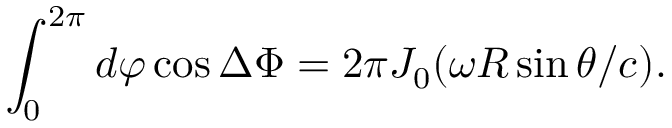<formula> <loc_0><loc_0><loc_500><loc_500>\int _ { 0 } ^ { 2 \pi } d \varphi \cos { \Delta \Phi } = 2 \pi J _ { 0 } ( \omega R \sin \theta / c ) .</formula> 